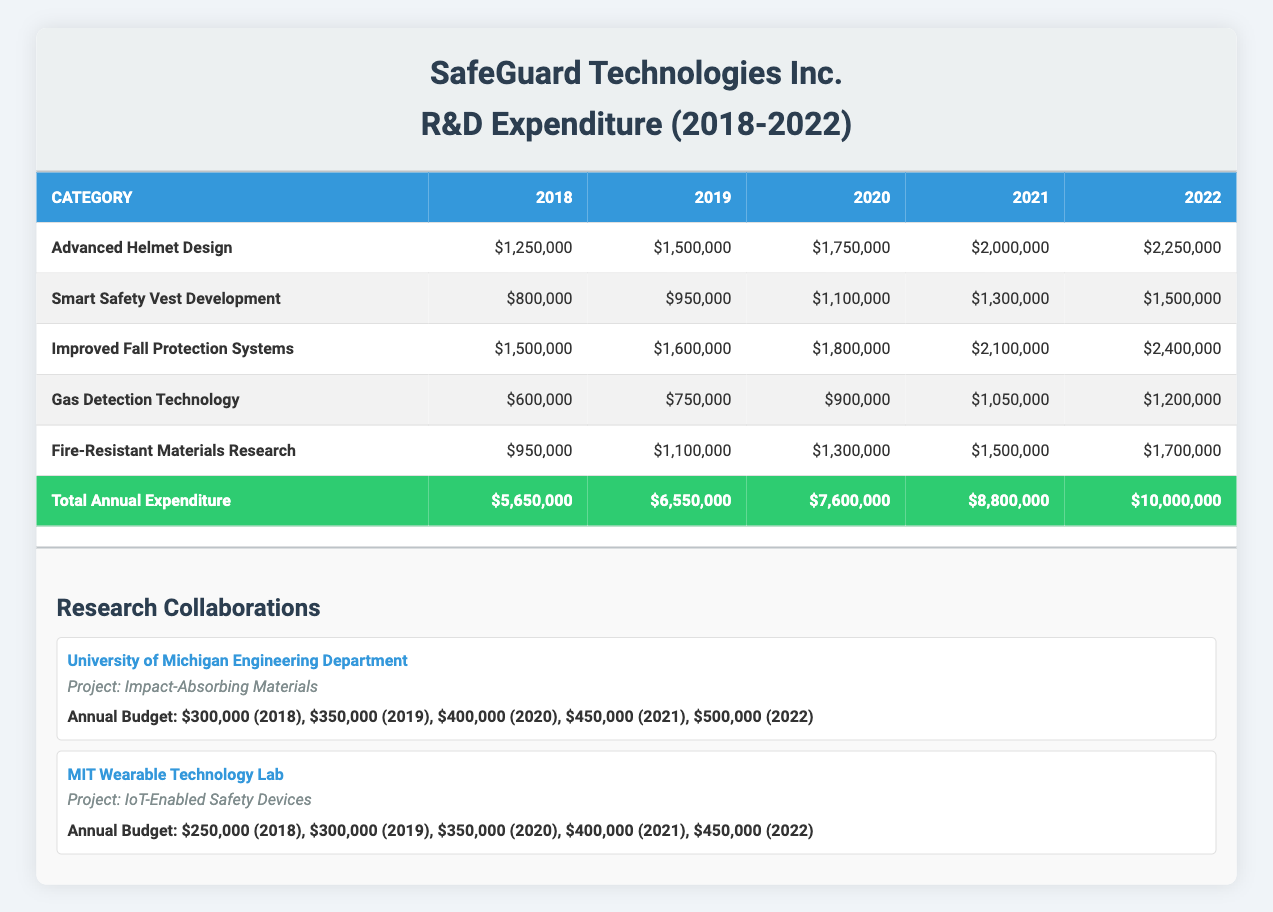What was the total expenditure for Advanced Helmet Design in 2020? By looking at the row for Advanced Helmet Design, the expenditure for the year 2020 is stated as $1,750,000.
Answer: $1,750,000 Which category had the highest expenditure in 2022? The last column shows the expenditures for each category in 2022. Comparing these, Improved Fall Protection Systems has the highest amount of $2,400,000.
Answer: Improved Fall Protection Systems What is the total annual expenditure in 2019? The total annual expenditure for 2019 is listed at the end of the second table as $6,550,000.
Answer: $6,550,000 What was the average annual budget for research collaborations over the last 5 years? The annual budgets for the two collaborations (University of Michigan and MIT) need to be summed for each year and then averaged. For University of Michigan, the total is $300,000 + $350,000 + $400,000 + $450,000 + $500,000 = $2,000,000. For MIT, the total is $250,000 + $300,000 + $350,000 + $400,000 + $450,000 = $1,750,000. Combined total is $2,000,000 + $1,750,000 = $3,750,000. The average over 5 years is $3,750,000 / 5 = $750,000.
Answer: $750,000 Did the expenditure for Gas Detection Technology increase every year? Looking at the row for Gas Detection Technology, the amounts are $600,000 for 2018, $750,000 for 2019, $900,000 for 2020, $1,050,000 for 2021, and $1,200,000 for 2022. Each amount is greater than the previous one, indicating a consistent increase.
Answer: Yes What is the total expenditure for Fire-Resistant Materials Research from 2018 to 2022? The values for Fire-Resistant Materials Research from 2018 to 2022 are summed: $950,000 + $1,100,000 + $1,300,000 + $1,500,000 + $1,700,000 = $5,550,000.
Answer: $5,550,000 Which category saw the smallest annual increase in expenditure from 2021 to 2022? To find out, we examine the expenditure for each category in 2021 and 2022. The increases are as follows: Advanced Helmet Design ($250,000), Smart Safety Vest Development ($200,000), Improved Fall Protection Systems ($300,000), Gas Detection Technology ($150,000), Fire-Resistant Materials Research ($200,000). The smallest increase was for Gas Detection Technology.
Answer: Gas Detection Technology What was the overall increase in total annual expenditure from 2018 to 2022? The total annual expenditure in 2018 was $5,650,000 and in 2022 it was $10,000,000. The increase is calculated by subtracting the 2018 total from the 2022 total: $10,000,000 - $5,650,000 = $4,350,000.
Answer: $4,350,000 